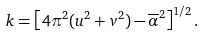Convert formula to latex. <formula><loc_0><loc_0><loc_500><loc_500>k = \left [ 4 \pi ^ { 2 } ( u ^ { 2 } + v ^ { 2 } ) - \overline { \alpha } ^ { 2 } \right ] ^ { 1 / 2 } .</formula> 